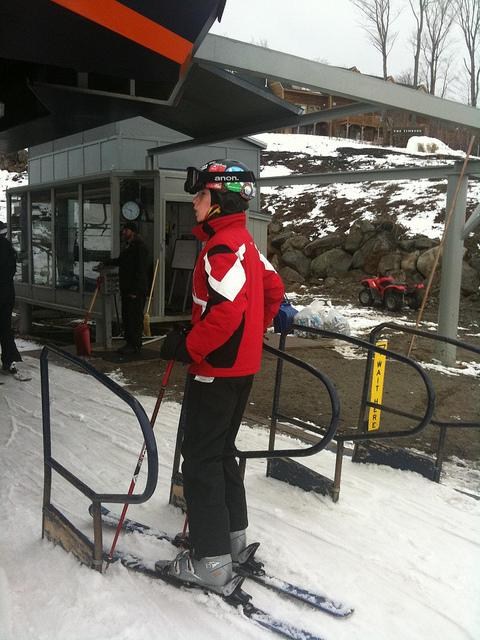What are the bars for? entry 